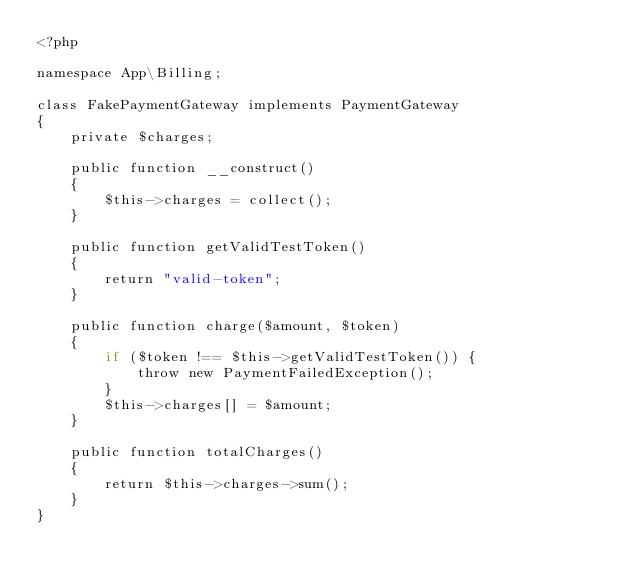Convert code to text. <code><loc_0><loc_0><loc_500><loc_500><_PHP_><?php

namespace App\Billing;

class FakePaymentGateway implements PaymentGateway
{
    private $charges;

    public function __construct()
    {
        $this->charges = collect();
    }

    public function getValidTestToken()
    {
        return "valid-token";
    }

    public function charge($amount, $token)
    {
        if ($token !== $this->getValidTestToken()) {
            throw new PaymentFailedException();
        }
        $this->charges[] = $amount;
    }

    public function totalCharges()
    {
        return $this->charges->sum();
    }
}</code> 